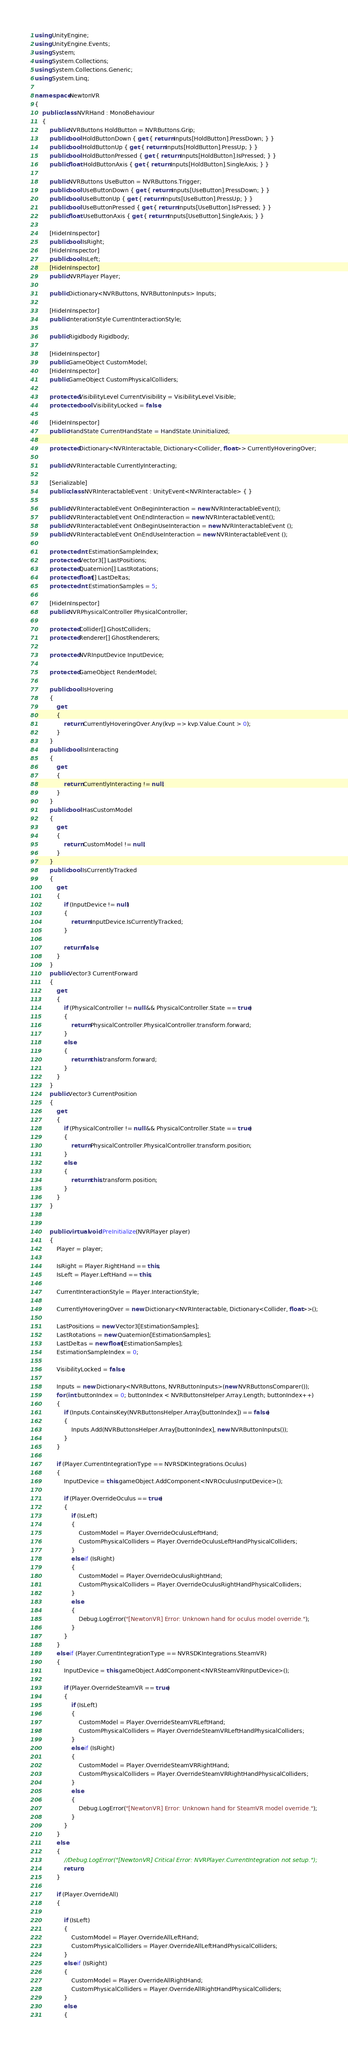Convert code to text. <code><loc_0><loc_0><loc_500><loc_500><_C#_>using UnityEngine;
using UnityEngine.Events;
using System;
using System.Collections;
using System.Collections.Generic;
using System.Linq;

namespace NewtonVR
{
    public class NVRHand : MonoBehaviour
    {
        public NVRButtons HoldButton = NVRButtons.Grip;
        public bool HoldButtonDown { get { return Inputs[HoldButton].PressDown; } }
        public bool HoldButtonUp { get { return Inputs[HoldButton].PressUp; } }
        public bool HoldButtonPressed { get { return Inputs[HoldButton].IsPressed; } }
        public float HoldButtonAxis { get { return Inputs[HoldButton].SingleAxis; } }

        public NVRButtons UseButton = NVRButtons.Trigger;
        public bool UseButtonDown { get { return Inputs[UseButton].PressDown; } }
        public bool UseButtonUp { get { return Inputs[UseButton].PressUp; } }
        public bool UseButtonPressed { get { return Inputs[UseButton].IsPressed; } }
        public float UseButtonAxis { get { return Inputs[UseButton].SingleAxis; } }

        [HideInInspector]
        public bool IsRight;
        [HideInInspector]
        public bool IsLeft;
        [HideInInspector]
        public NVRPlayer Player;

        public Dictionary<NVRButtons, NVRButtonInputs> Inputs;

        [HideInInspector]
        public InterationStyle CurrentInteractionStyle;

        public Rigidbody Rigidbody;

        [HideInInspector]
        public GameObject CustomModel;
        [HideInInspector]
        public GameObject CustomPhysicalColliders;

        protected VisibilityLevel CurrentVisibility = VisibilityLevel.Visible;
        protected bool VisibilityLocked = false;

        [HideInInspector]
        public HandState CurrentHandState = HandState.Uninitialized;

        protected Dictionary<NVRInteractable, Dictionary<Collider, float>> CurrentlyHoveringOver;

        public NVRInteractable CurrentlyInteracting;

        [Serializable]
        public class NVRInteractableEvent : UnityEvent<NVRInteractable> { }

        public NVRInteractableEvent OnBeginInteraction = new NVRInteractableEvent();
        public NVRInteractableEvent OnEndInteraction = new NVRInteractableEvent();
        public NVRInteractableEvent OnBeginUseInteraction = new NVRInteractableEvent ();
        public NVRInteractableEvent OnEndUseInteraction = new NVRInteractableEvent ();

        protected int EstimationSampleIndex;
        protected Vector3[] LastPositions;
        protected Quaternion[] LastRotations;
        protected float[] LastDeltas;
        protected int EstimationSamples = 5;

        [HideInInspector]
        public NVRPhysicalController PhysicalController;

        protected Collider[] GhostColliders;
        protected Renderer[] GhostRenderers;

        protected NVRInputDevice InputDevice;

        protected GameObject RenderModel;

        public bool IsHovering
        {
            get
            {
                return CurrentlyHoveringOver.Any(kvp => kvp.Value.Count > 0);
            }
        }
        public bool IsInteracting
        {
            get
            {
                return CurrentlyInteracting != null;
            }
        }
        public bool HasCustomModel
        {
            get
            {
                return CustomModel != null;
            }
        }
        public bool IsCurrentlyTracked
        {
            get
            {
                if (InputDevice != null)
                {
                    return InputDevice.IsCurrentlyTracked;
                }

                return false;
            }
        }
        public Vector3 CurrentForward
        {
            get
            {
                if (PhysicalController != null && PhysicalController.State == true)
                {
                    return PhysicalController.PhysicalController.transform.forward;
                }
                else
                {
                    return this.transform.forward;
                }
            }
        }
        public Vector3 CurrentPosition
        {
            get
            {
                if (PhysicalController != null && PhysicalController.State == true)
                {
                    return PhysicalController.PhysicalController.transform.position;
                }
                else
                {
                    return this.transform.position;
                }
            }
        }


        public virtual void PreInitialize(NVRPlayer player)
        {
            Player = player;

            IsRight = Player.RightHand == this;
            IsLeft = Player.LeftHand == this;

            CurrentInteractionStyle = Player.InteractionStyle;

            CurrentlyHoveringOver = new Dictionary<NVRInteractable, Dictionary<Collider, float>>();

            LastPositions = new Vector3[EstimationSamples];
            LastRotations = new Quaternion[EstimationSamples];
            LastDeltas = new float[EstimationSamples];
            EstimationSampleIndex = 0;

            VisibilityLocked = false;

            Inputs = new Dictionary<NVRButtons, NVRButtonInputs>(new NVRButtonsComparer());
            for (int buttonIndex = 0; buttonIndex < NVRButtonsHelper.Array.Length; buttonIndex++)
            {
                if (Inputs.ContainsKey(NVRButtonsHelper.Array[buttonIndex]) == false)
                {
                    Inputs.Add(NVRButtonsHelper.Array[buttonIndex], new NVRButtonInputs());
                }
            }

            if (Player.CurrentIntegrationType == NVRSDKIntegrations.Oculus)
            {
                InputDevice = this.gameObject.AddComponent<NVROculusInputDevice>();

                if (Player.OverrideOculus == true)
                {
                    if (IsLeft)
                    {
                        CustomModel = Player.OverrideOculusLeftHand;
                        CustomPhysicalColliders = Player.OverrideOculusLeftHandPhysicalColliders;
                    }
                    else if (IsRight)
                    {
                        CustomModel = Player.OverrideOculusRightHand;
                        CustomPhysicalColliders = Player.OverrideOculusRightHandPhysicalColliders;
                    }
                    else
                    {
                        Debug.LogError("[NewtonVR] Error: Unknown hand for oculus model override.");
                    }
                }
            }
            else if (Player.CurrentIntegrationType == NVRSDKIntegrations.SteamVR)
            {
                InputDevice = this.gameObject.AddComponent<NVRSteamVRInputDevice>();

                if (Player.OverrideSteamVR == true)
                {
                    if (IsLeft)
                    {
                        CustomModel = Player.OverrideSteamVRLeftHand;
                        CustomPhysicalColliders = Player.OverrideSteamVRLeftHandPhysicalColliders;
                    }
                    else if (IsRight)
                    {
                        CustomModel = Player.OverrideSteamVRRightHand;
                        CustomPhysicalColliders = Player.OverrideSteamVRRightHandPhysicalColliders;
                    }
                    else
                    {
                        Debug.LogError("[NewtonVR] Error: Unknown hand for SteamVR model override.");
                    }
                }
            }
            else
            {
                //Debug.LogError("[NewtonVR] Critical Error: NVRPlayer.CurrentIntegration not setup.");
                return;
            }

            if (Player.OverrideAll)
            {

                if (IsLeft)
                {
                    CustomModel = Player.OverrideAllLeftHand;
                    CustomPhysicalColliders = Player.OverrideAllLeftHandPhysicalColliders;
                }
                else if (IsRight)
                {
                    CustomModel = Player.OverrideAllRightHand;
                    CustomPhysicalColliders = Player.OverrideAllRightHandPhysicalColliders;
                }
                else
                {</code> 